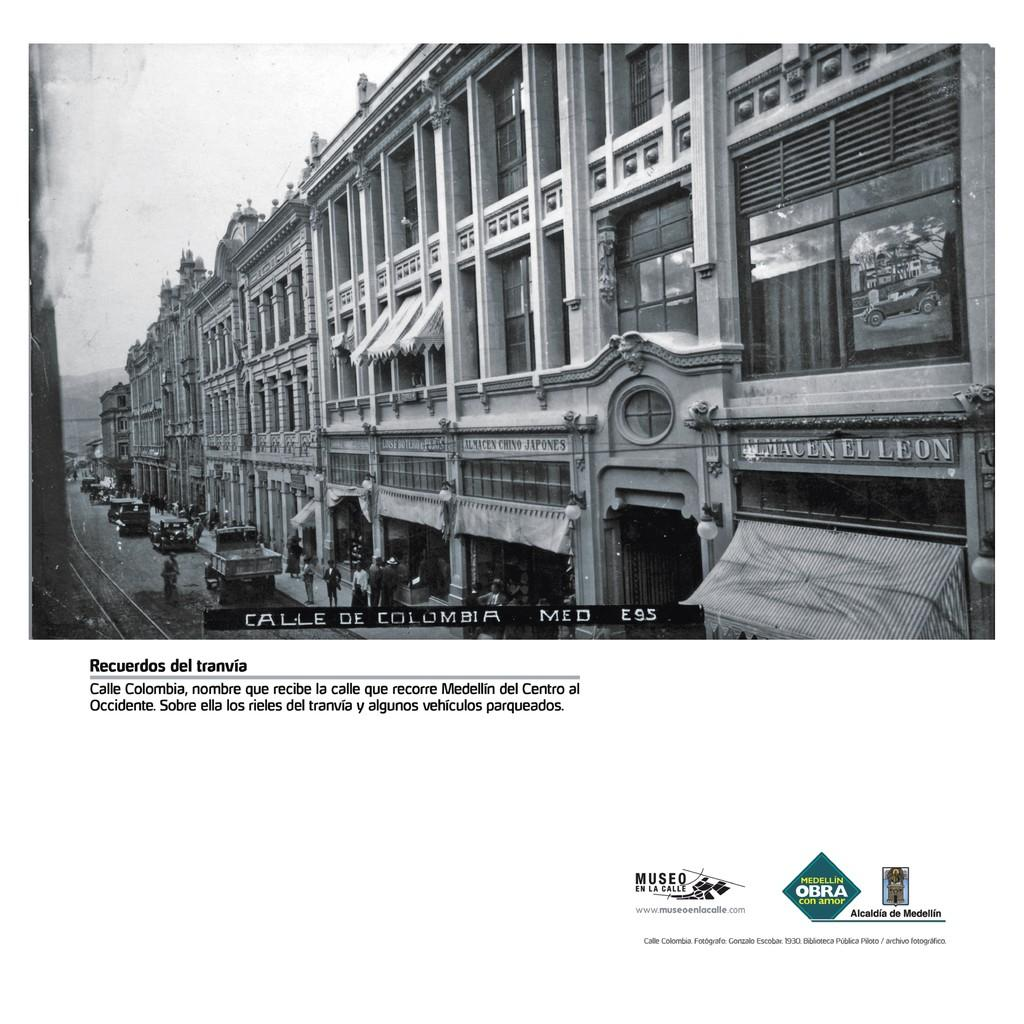What is the main subject of the poster in the image? The main subject of the poster in the image is a scene that includes buildings, vehicles, people, text, the sky, and hills. Can you describe the scene depicted in the middle of the poster? The middle of the poster contains buildings, vehicles, people, text, and the sky. Are there any natural elements in the scene depicted in the middle of the poster? Yes, there are hills in the middle of the poster. Is there any text present on the poster? Yes, there is text in the middle of the poster and at the bottom of the poster. Can you tell me how many pigs are depicted in the scene on the poster? There are no pigs depicted in the scene on the poster; the image features buildings, vehicles, people, text, the sky, and hills. How do the people in the scene on the poster interact with the fly? There is no fly present in the scene on the poster; it only features buildings, vehicles, people, text, the sky, and hills. 